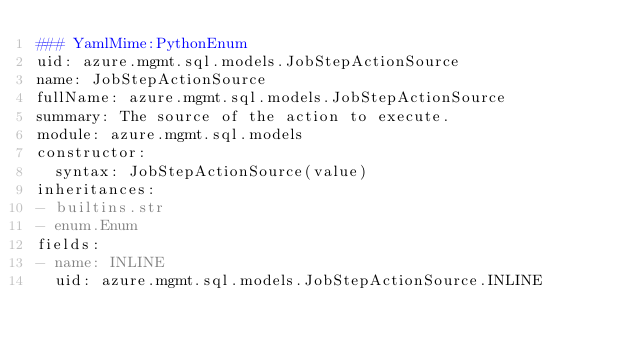<code> <loc_0><loc_0><loc_500><loc_500><_YAML_>### YamlMime:PythonEnum
uid: azure.mgmt.sql.models.JobStepActionSource
name: JobStepActionSource
fullName: azure.mgmt.sql.models.JobStepActionSource
summary: The source of the action to execute.
module: azure.mgmt.sql.models
constructor:
  syntax: JobStepActionSource(value)
inheritances:
- builtins.str
- enum.Enum
fields:
- name: INLINE
  uid: azure.mgmt.sql.models.JobStepActionSource.INLINE
</code> 